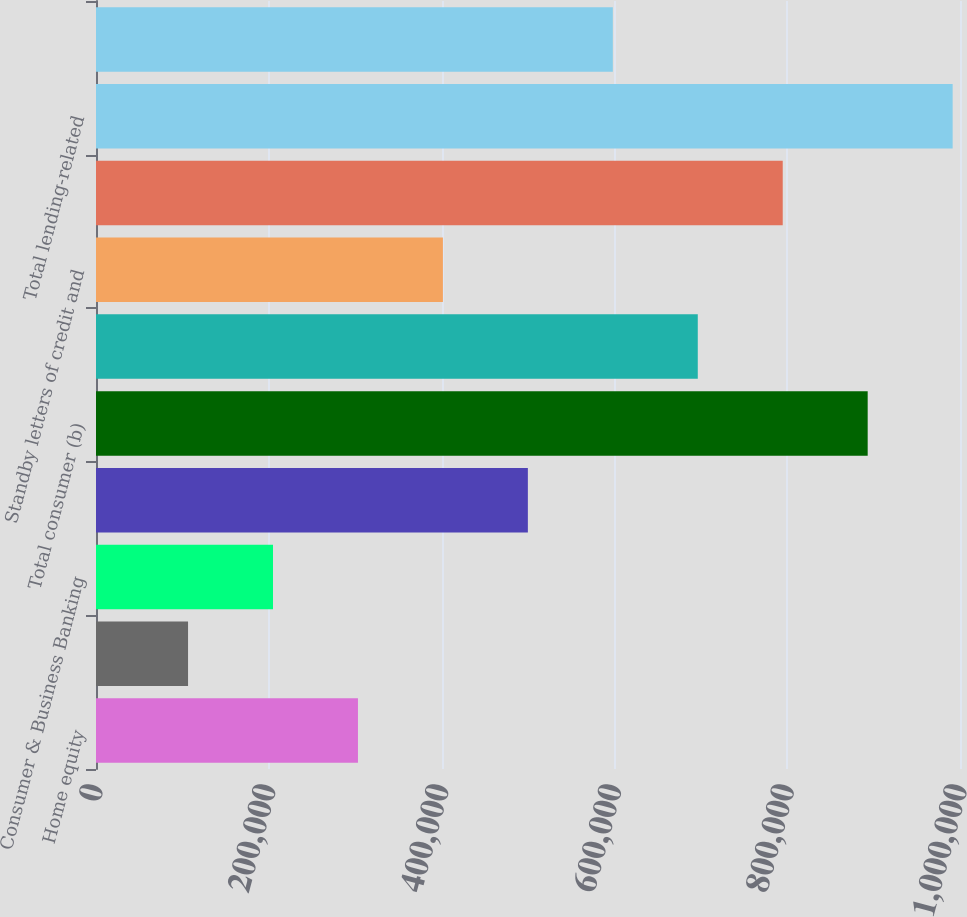Convert chart. <chart><loc_0><loc_0><loc_500><loc_500><bar_chart><fcel>Home equity<fcel>Auto<fcel>Consumer & Business Banking<fcel>Total consumer excluding<fcel>Total consumer (b)<fcel>Other unfunded commitments to<fcel>Standby letters of credit and<fcel>Total wholesale (d)<fcel>Total lending-related<fcel>Derivatives qualifying as<nl><fcel>303189<fcel>106534<fcel>204861<fcel>499844<fcel>893154<fcel>696499<fcel>401516<fcel>794827<fcel>991482<fcel>598172<nl></chart> 